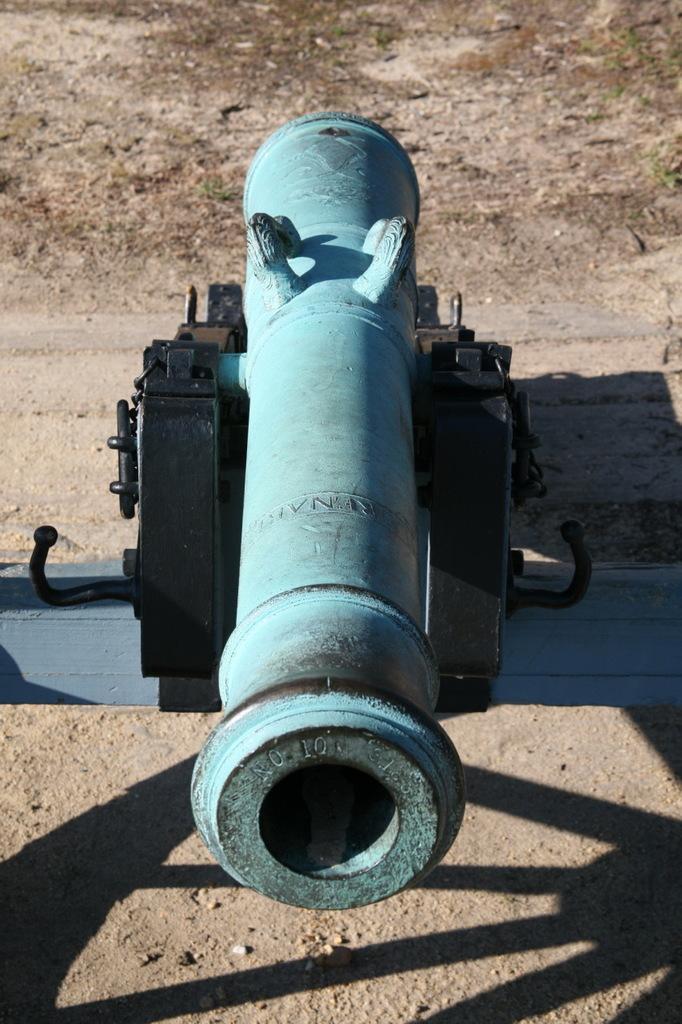Could you give a brief overview of what you see in this image? In this picture I see a canon which is of blue and black in color and it is on the ground and I see the shadow on ground in front. 